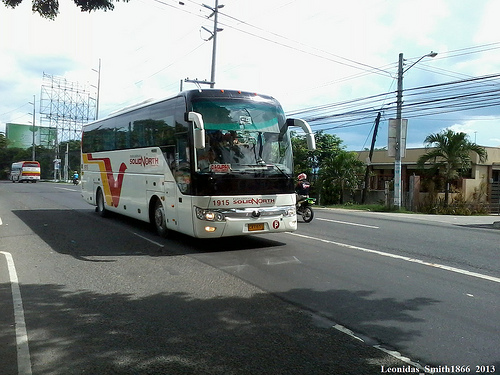Please provide the bounding box coordinate of the region this sentence describes: white clouds in blue sky. The bounding box for the region showing white clouds in a blue sky should be approximately from (0.46, 0.15) to (0.53, 0.23). 